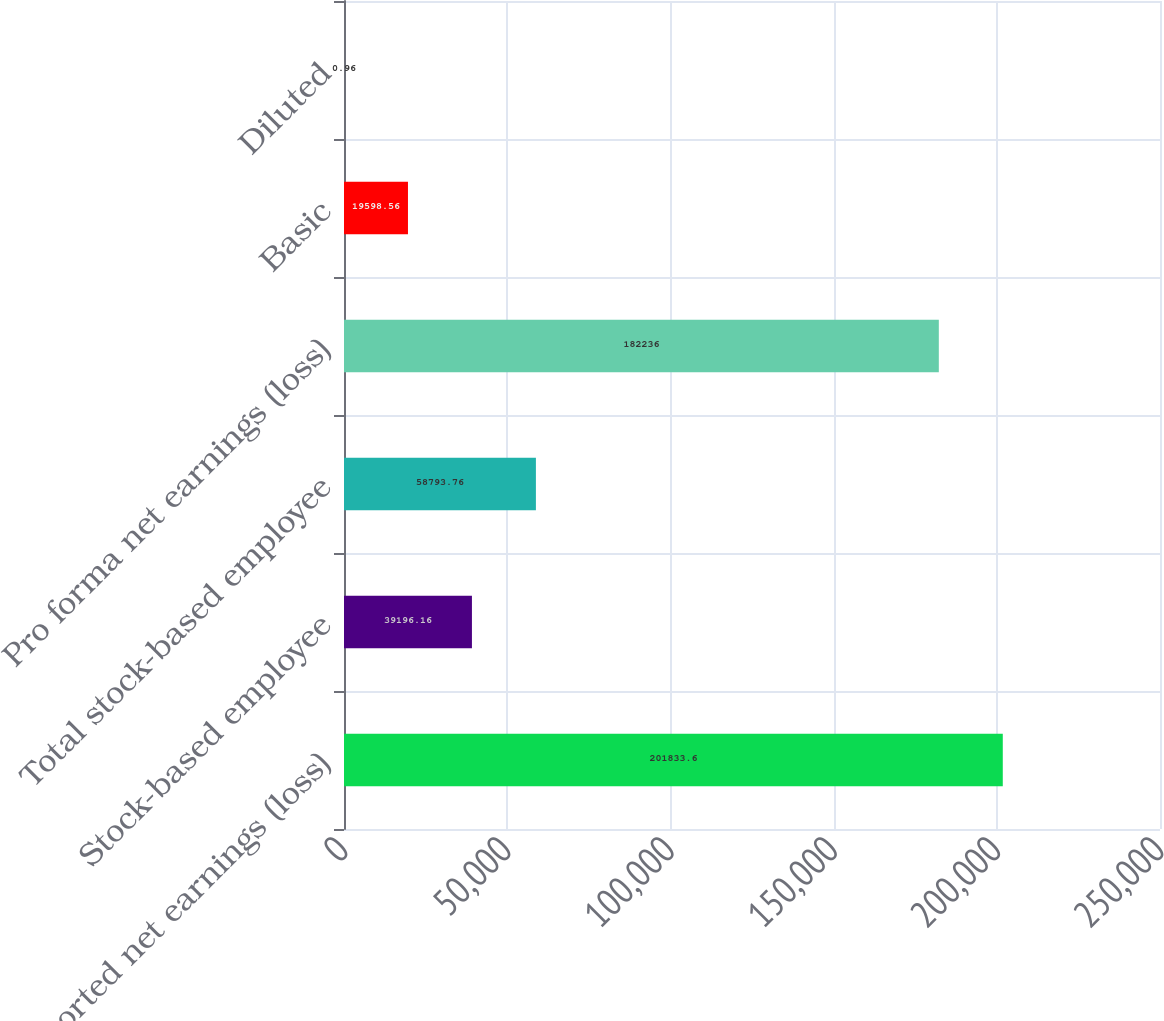Convert chart. <chart><loc_0><loc_0><loc_500><loc_500><bar_chart><fcel>Reported net earnings (loss)<fcel>Stock-based employee<fcel>Total stock-based employee<fcel>Pro forma net earnings (loss)<fcel>Basic<fcel>Diluted<nl><fcel>201834<fcel>39196.2<fcel>58793.8<fcel>182236<fcel>19598.6<fcel>0.96<nl></chart> 